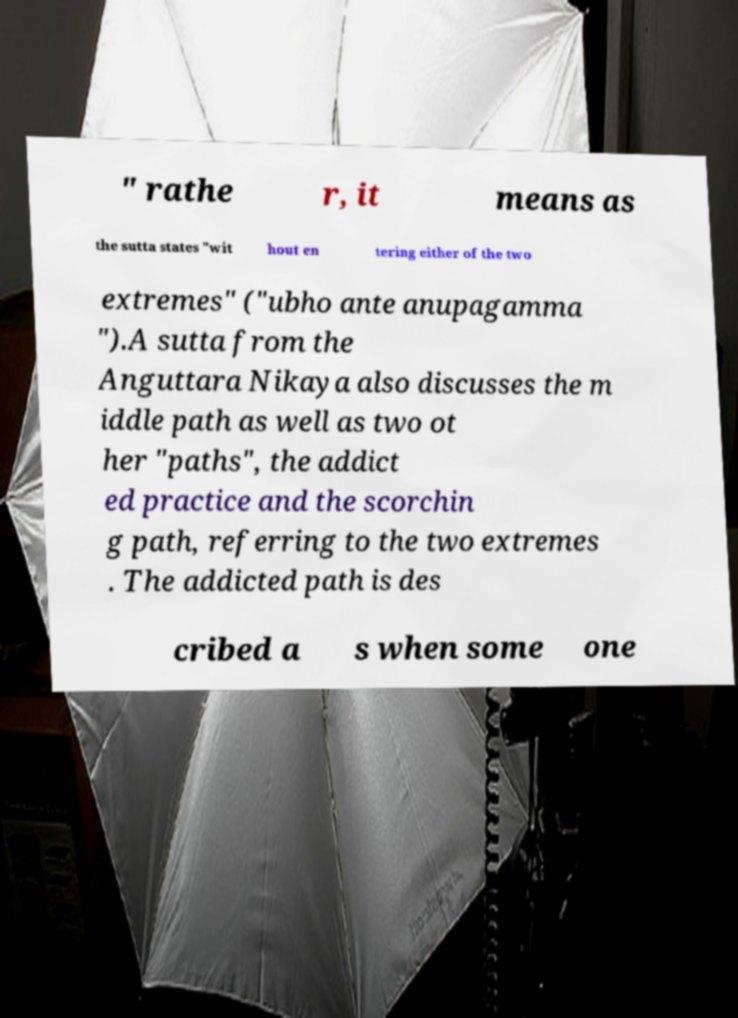Can you read and provide the text displayed in the image?This photo seems to have some interesting text. Can you extract and type it out for me? " rathe r, it means as the sutta states "wit hout en tering either of the two extremes" ("ubho ante anupagamma ").A sutta from the Anguttara Nikaya also discusses the m iddle path as well as two ot her "paths", the addict ed practice and the scorchin g path, referring to the two extremes . The addicted path is des cribed a s when some one 